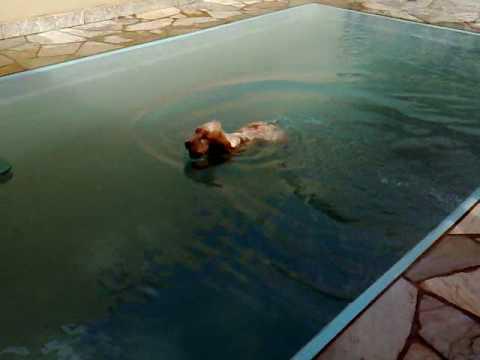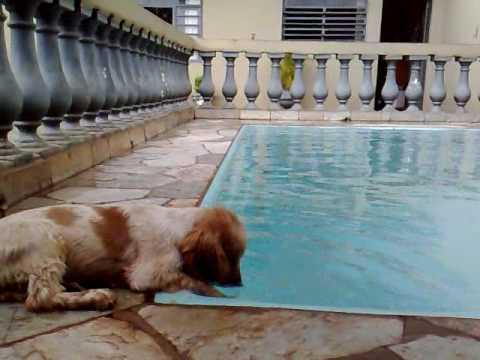The first image is the image on the left, the second image is the image on the right. For the images shown, is this caption "One tennis ball is in both images." true? Answer yes or no. No. The first image is the image on the left, the second image is the image on the right. For the images shown, is this caption "In one of the images, there is a dog swimming while carrying an object in its mouth." true? Answer yes or no. No. 